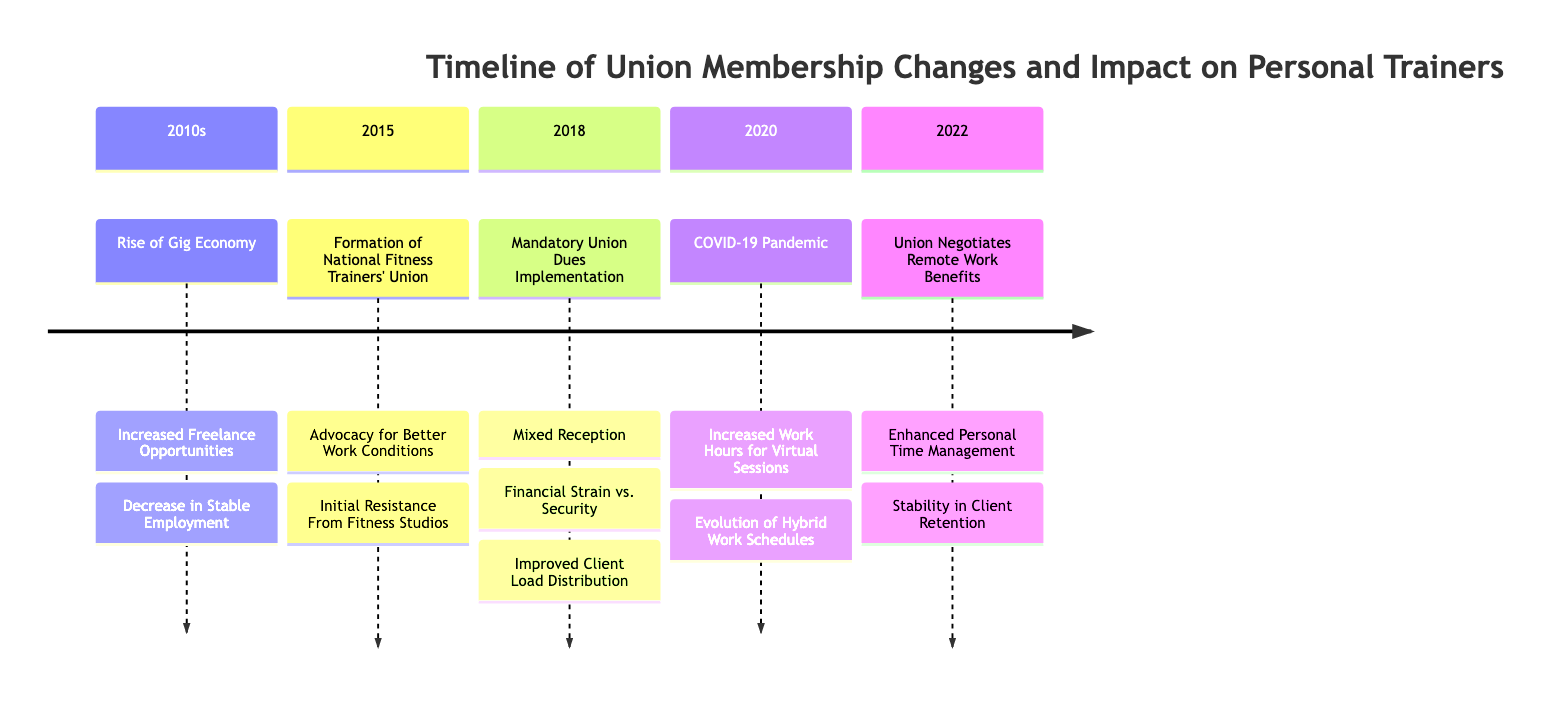What significant event occurred in 2015? The diagram indicates that the formation of the National Fitness Trainers' Union took place in 2015, which is highlighted as a significant event in that section.
Answer: Formation of National Fitness Trainers' Union What was the primary impact on personal trainers in 2018? In 2018, the diagram notes that the implementation of mandatory union dues created a mixed reception, particularly addressing financial strain versus security while also improving client load distribution.
Answer: Improved Client Load Distribution How did the COVID-19 pandemic affect work hours in 2020? According to the timeline in the diagram, the COVID-19 pandemic led to increased work hours for virtual sessions for personal trainers, which is an important outcome highlighted in that section.
Answer: Increased Work Hours for Virtual Sessions What year did the union negotiate remote work benefits? The diagram shows that the union negotiated remote work benefits in the year 2022, providing clarity on a specific event in the timeline.
Answer: 2022 What trend related to employment opportunities began in the 2010s? The diagram states that in the 2010s, there was a rise of the gig economy, which led to increased freelance opportunities but also a decrease in stable employment for personal trainers.
Answer: Increased Freelance Opportunities Which event showed initial resistance from fitness studios? The chart specifies the formation of the National Fitness Trainers' Union in 2015 as an event that faced initial resistance from fitness studios, highlighting a conflict that arose during that time.
Answer: Initial Resistance From Fitness Studios What was a consequence of union dues in 2018? The timeline indicates that a consequence of mandatory union dues implementation in 2018 was the mixed reception of financial strain versus security, reflecting the varied reactions from personal trainers.
Answer: Mixed Reception: Financial Strain vs. Security How did the union aim to enhance personal time for trainers in 2022? The diagram indicates that in 2022, the union negotiated remote work benefits, which was aimed at enhancing personal time management for personal trainers.
Answer: Enhanced Personal Time Management 